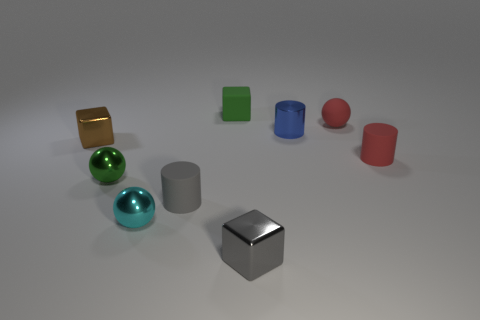How does the lighting appear to affect the objects? The lighting creates highlights and shadows that give the objects a three-dimensional appearance, enhancing their textures and the perception of their material properties.  Does the light source come from a particular direction? Yes, the light appears to be coming from the upper left, as indicated by the shadows being cast towards the lower right. 